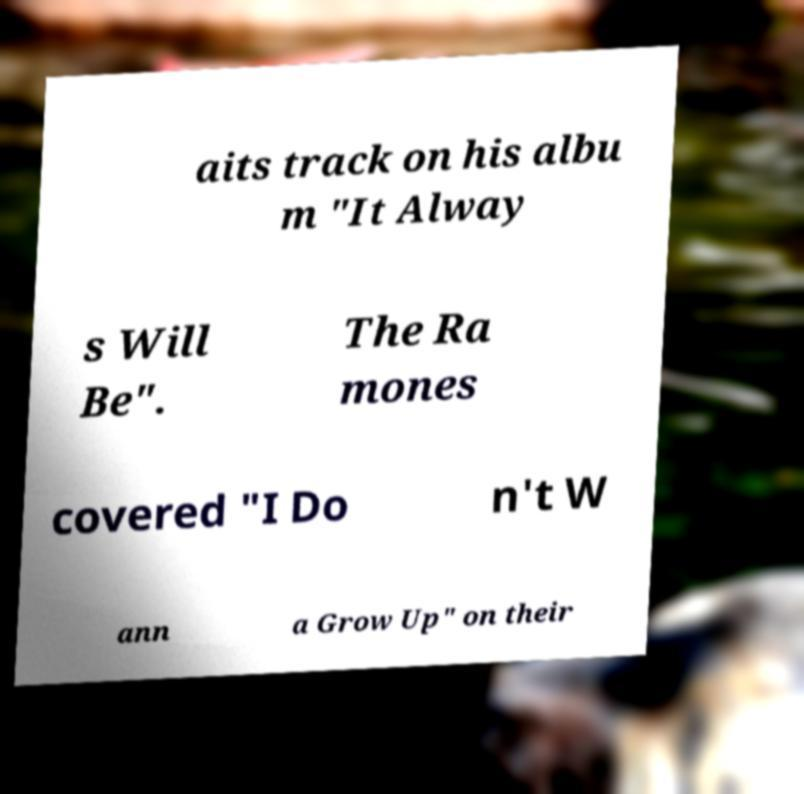Please read and relay the text visible in this image. What does it say? aits track on his albu m "It Alway s Will Be". The Ra mones covered "I Do n't W ann a Grow Up" on their 